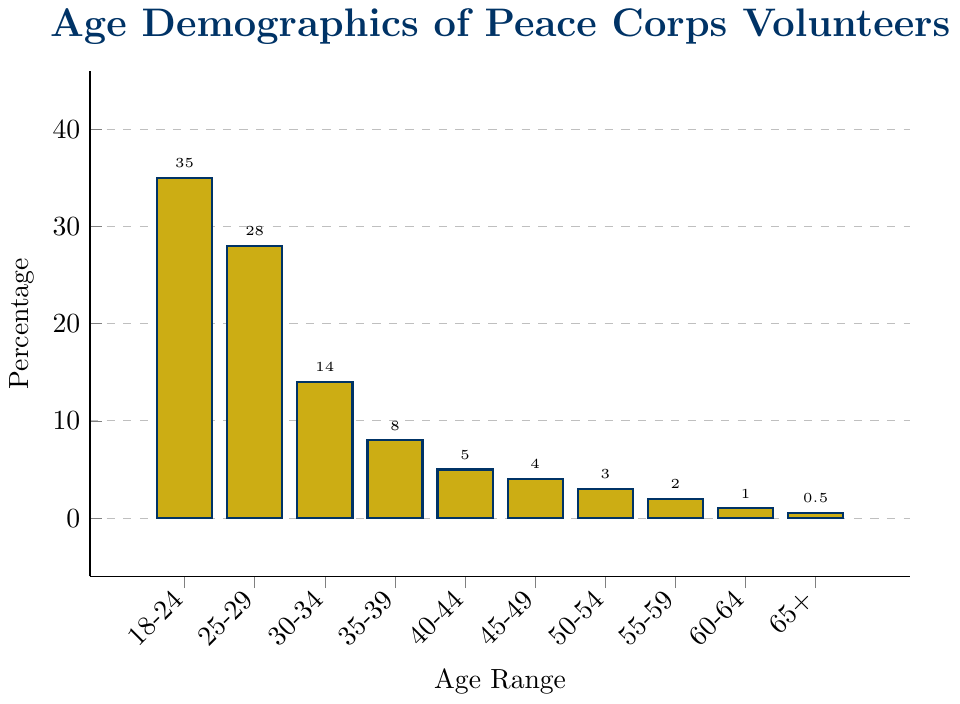How many age groups have a percentage higher than 10%? Identify each age group and their respective percentages. The age groups with percentages higher than 10% are 18-24 (35%), 25-29 (28%), and 30-34 (14%). Count these groups.
Answer: 3 What is the sum of the percentages for volunteers aged 35-39 and 40-44? Look at the bars for the age groups 35-39 and 40-44. Their percentages are 8% and 5% respectively. The sum is 8% + 5% = 13%.
Answer: 13% Which age group has the lowest percentage of volunteers? Identify the bar with the shortest height. The age group with the shortest bar corresponds to the 65+ age range with 0.5%.
Answer: 65+ Is the number of volunteers aged 45-49 greater than those aged 50-54? Compare the heights of the bars for 45-49 and 50-54. The 45-49 age group has a percentage of 4%, and the 50-54 age group has a percentage of 3%. So 4% > 3%.
Answer: Yes Which age range has a percentage exactly half of the 25-29 age range? The percentage for the 25-29 age range is 28%. Half of this percentage is 28% / 2 = 14%. The 30-34 age range has 14%, which is exactly half of 28%.
Answer: 30-34 What is the difference in percentage between the youngest age group (18-24) and the oldest age group (65+)? The percentage for the 18-24 age group is 35%, and for the 65+ age group, it is 0.5%. The difference is 35% - 0.5% = 34.5%.
Answer: 34.5% What is the visual attribute that helps identify the age group with the highest percentage? Look for the bar with the greatest height and also notice the color used for all bars. The tallest bar corresponds to the age range 18-24, and the bars are colored yellow-blue.
Answer: Tallest bar Which two consecutive age groups have the most noticeable drop in volunteer percentages? Compare the differences between each consecutive pair of bars. The largest drop is between 25-29 (28%) and 30-34 (14%), with a difference of 28% - 14% = 14%.
Answer: 25-29, 30-34 What is the total percentage of volunteers aged 50 and older? Sum the percentages for age groups 50-54, 55-59, 60-64, and 65+. These percentages are 3%, 2%, 1%, and 0.5% respectively. Total = 3% + 2% + 1% + 0.5% = 6.5%.
Answer: 6.5% 